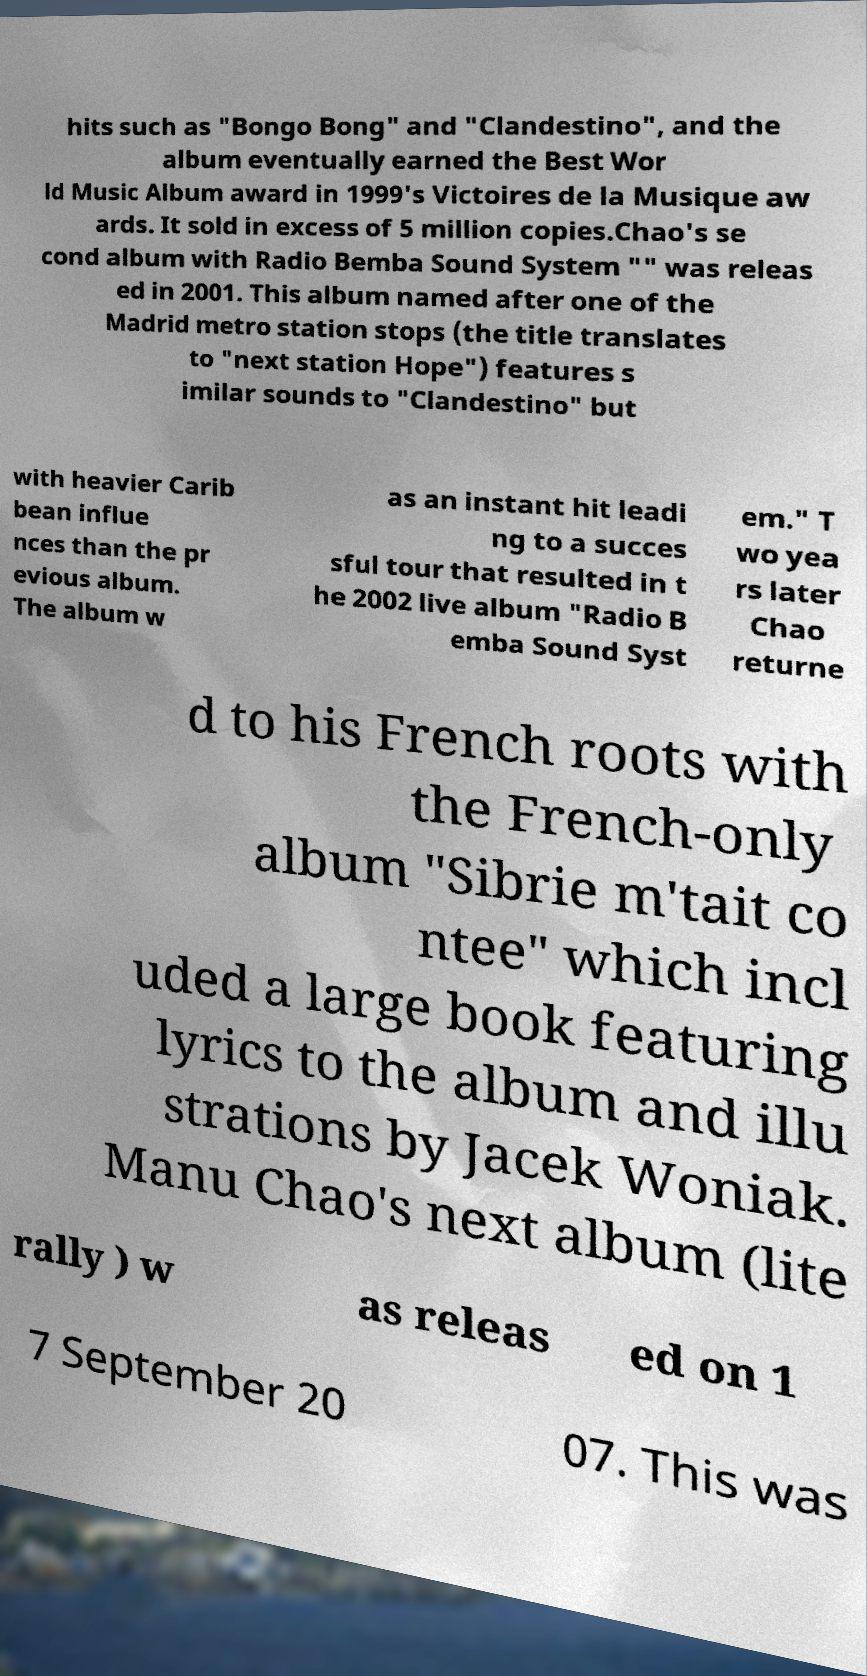Can you read and provide the text displayed in the image?This photo seems to have some interesting text. Can you extract and type it out for me? hits such as "Bongo Bong" and "Clandestino", and the album eventually earned the Best Wor ld Music Album award in 1999's Victoires de la Musique aw ards. It sold in excess of 5 million copies.Chao's se cond album with Radio Bemba Sound System "" was releas ed in 2001. This album named after one of the Madrid metro station stops (the title translates to "next station Hope") features s imilar sounds to "Clandestino" but with heavier Carib bean influe nces than the pr evious album. The album w as an instant hit leadi ng to a succes sful tour that resulted in t he 2002 live album "Radio B emba Sound Syst em." T wo yea rs later Chao returne d to his French roots with the French-only album "Sibrie m'tait co ntee" which incl uded a large book featuring lyrics to the album and illu strations by Jacek Woniak. Manu Chao's next album (lite rally ) w as releas ed on 1 7 September 20 07. This was 